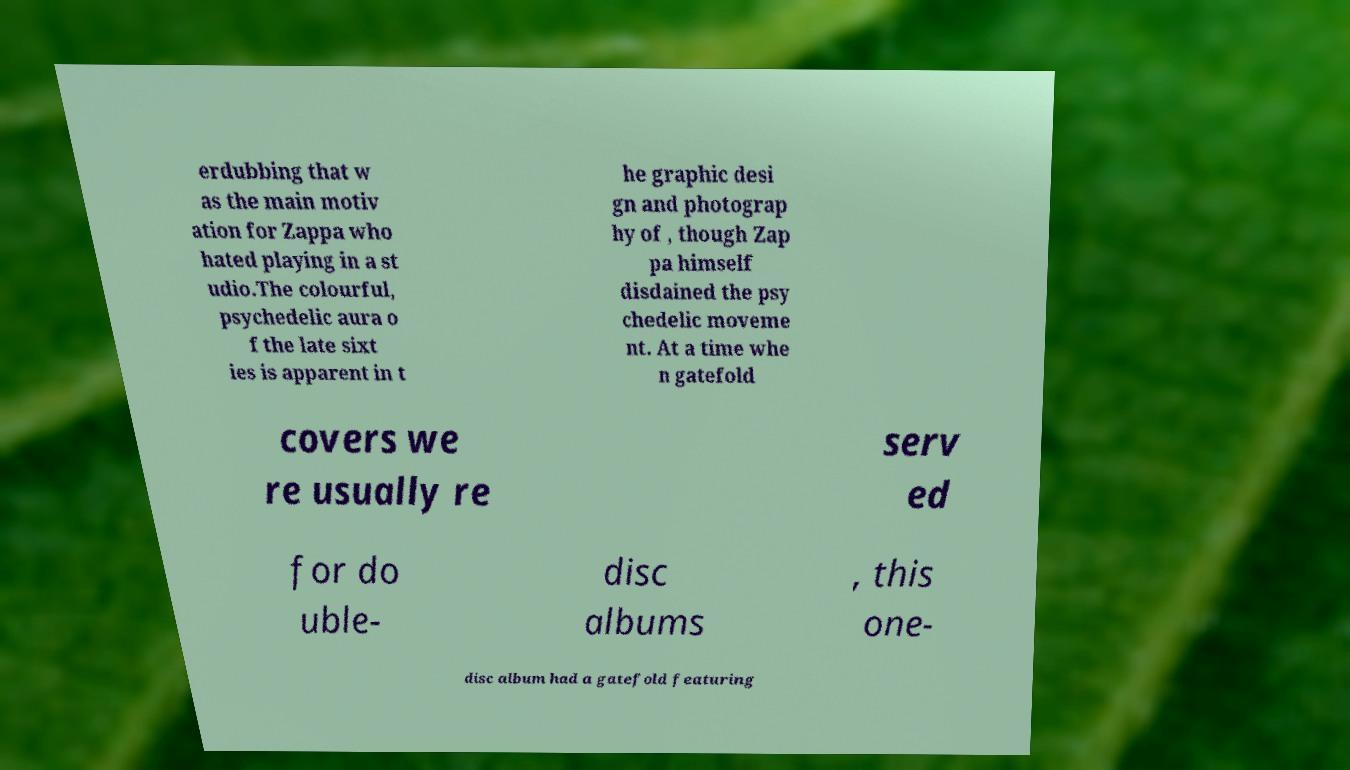What messages or text are displayed in this image? I need them in a readable, typed format. erdubbing that w as the main motiv ation for Zappa who hated playing in a st udio.The colourful, psychedelic aura o f the late sixt ies is apparent in t he graphic desi gn and photograp hy of , though Zap pa himself disdained the psy chedelic moveme nt. At a time whe n gatefold covers we re usually re serv ed for do uble- disc albums , this one- disc album had a gatefold featuring 